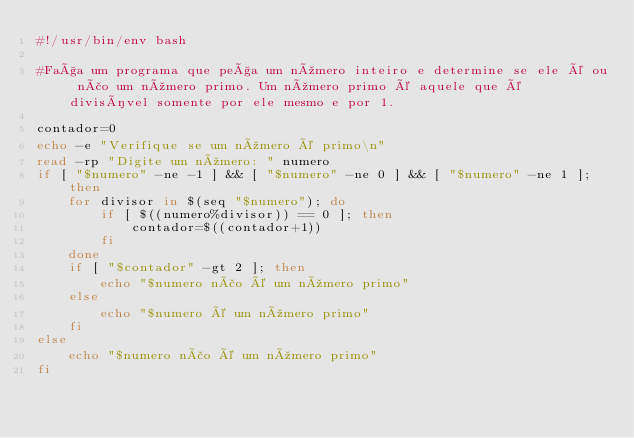<code> <loc_0><loc_0><loc_500><loc_500><_Bash_>#!/usr/bin/env bash

#Faça um programa que peça um número inteiro e determine se ele é ou não um número primo. Um número primo é aquele que é divisível somente por ele mesmo e por 1.

contador=0
echo -e "Verifique se um número é primo\n"
read -rp "Digite um número: " numero
if [ "$numero" -ne -1 ] && [ "$numero" -ne 0 ] && [ "$numero" -ne 1 ]; then
    for divisor in $(seq "$numero"); do
        if [ $((numero%divisor)) == 0 ]; then
            contador=$((contador+1))
        fi
    done    
    if [ "$contador" -gt 2 ]; then
        echo "$numero não é um número primo"
    else
        echo "$numero é um número primo"
    fi
else
    echo "$numero não é um número primo"
fi
</code> 